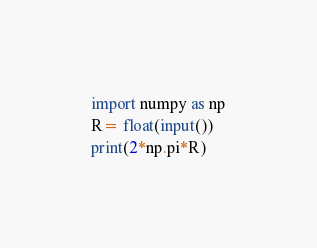<code> <loc_0><loc_0><loc_500><loc_500><_Python_>import numpy as np
R= float(input())
print(2*np.pi*R)</code> 